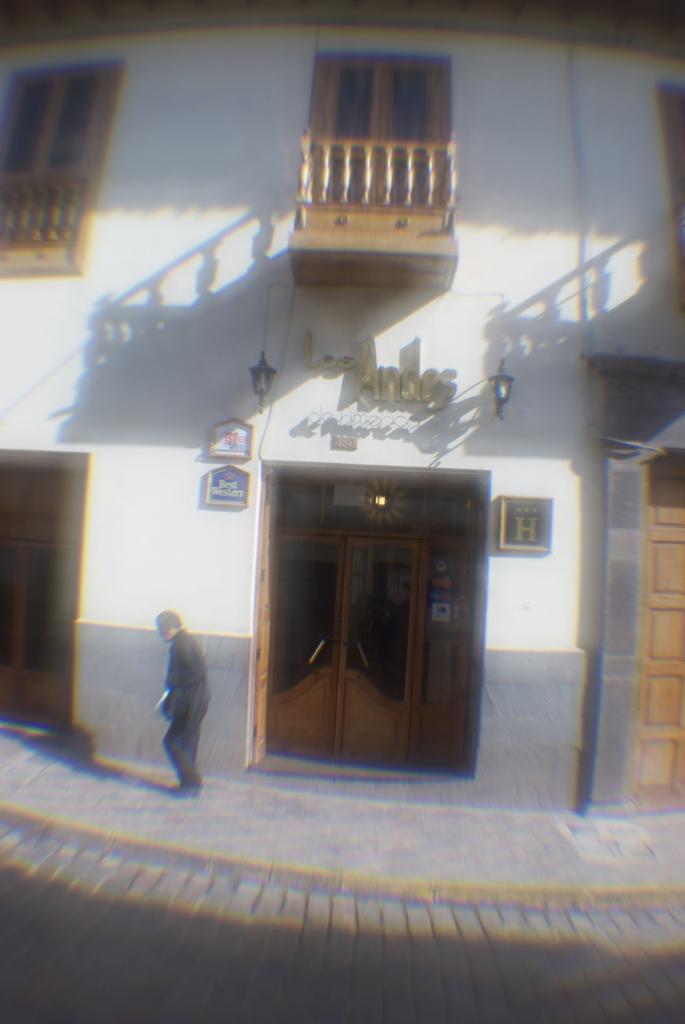Please provide a concise description of this image. At the bottom of the image on the footpath there is a man. Behind him there is a wall with doors, windows, railings, lamps and frames. 